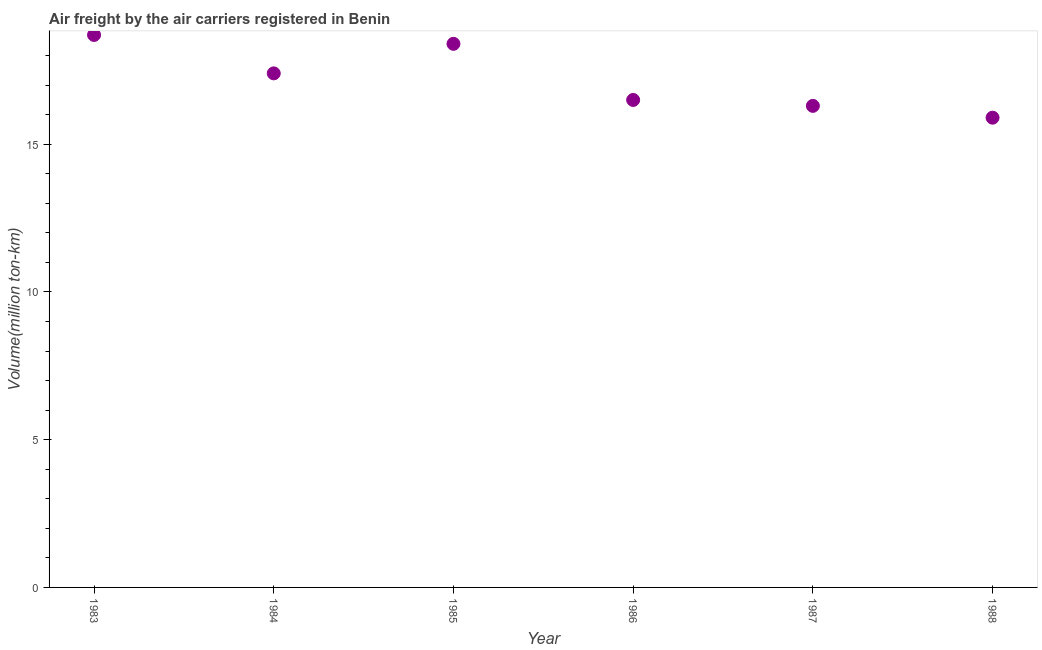What is the air freight in 1986?
Your response must be concise. 16.5. Across all years, what is the maximum air freight?
Keep it short and to the point. 18.7. Across all years, what is the minimum air freight?
Keep it short and to the point. 15.9. What is the sum of the air freight?
Your answer should be very brief. 103.2. What is the difference between the air freight in 1983 and 1986?
Offer a very short reply. 2.2. What is the average air freight per year?
Provide a short and direct response. 17.2. What is the median air freight?
Provide a succinct answer. 16.95. In how many years, is the air freight greater than 16 million ton-km?
Your answer should be compact. 5. Do a majority of the years between 1984 and 1983 (inclusive) have air freight greater than 8 million ton-km?
Offer a very short reply. No. What is the ratio of the air freight in 1984 to that in 1985?
Your answer should be compact. 0.95. Is the air freight in 1986 less than that in 1987?
Give a very brief answer. No. What is the difference between the highest and the second highest air freight?
Provide a short and direct response. 0.3. What is the difference between the highest and the lowest air freight?
Keep it short and to the point. 2.8. In how many years, is the air freight greater than the average air freight taken over all years?
Ensure brevity in your answer.  3. How many dotlines are there?
Provide a succinct answer. 1. What is the difference between two consecutive major ticks on the Y-axis?
Provide a succinct answer. 5. Does the graph contain grids?
Your response must be concise. No. What is the title of the graph?
Provide a succinct answer. Air freight by the air carriers registered in Benin. What is the label or title of the Y-axis?
Ensure brevity in your answer.  Volume(million ton-km). What is the Volume(million ton-km) in 1983?
Ensure brevity in your answer.  18.7. What is the Volume(million ton-km) in 1984?
Offer a terse response. 17.4. What is the Volume(million ton-km) in 1985?
Provide a succinct answer. 18.4. What is the Volume(million ton-km) in 1986?
Your response must be concise. 16.5. What is the Volume(million ton-km) in 1987?
Keep it short and to the point. 16.3. What is the Volume(million ton-km) in 1988?
Offer a terse response. 15.9. What is the difference between the Volume(million ton-km) in 1983 and 1984?
Offer a very short reply. 1.3. What is the difference between the Volume(million ton-km) in 1984 and 1985?
Your answer should be very brief. -1. What is the difference between the Volume(million ton-km) in 1984 and 1986?
Make the answer very short. 0.9. What is the difference between the Volume(million ton-km) in 1984 and 1987?
Provide a succinct answer. 1.1. What is the ratio of the Volume(million ton-km) in 1983 to that in 1984?
Give a very brief answer. 1.07. What is the ratio of the Volume(million ton-km) in 1983 to that in 1986?
Your answer should be very brief. 1.13. What is the ratio of the Volume(million ton-km) in 1983 to that in 1987?
Offer a terse response. 1.15. What is the ratio of the Volume(million ton-km) in 1983 to that in 1988?
Your response must be concise. 1.18. What is the ratio of the Volume(million ton-km) in 1984 to that in 1985?
Offer a terse response. 0.95. What is the ratio of the Volume(million ton-km) in 1984 to that in 1986?
Your response must be concise. 1.05. What is the ratio of the Volume(million ton-km) in 1984 to that in 1987?
Offer a very short reply. 1.07. What is the ratio of the Volume(million ton-km) in 1984 to that in 1988?
Ensure brevity in your answer.  1.09. What is the ratio of the Volume(million ton-km) in 1985 to that in 1986?
Offer a terse response. 1.11. What is the ratio of the Volume(million ton-km) in 1985 to that in 1987?
Keep it short and to the point. 1.13. What is the ratio of the Volume(million ton-km) in 1985 to that in 1988?
Offer a terse response. 1.16. What is the ratio of the Volume(million ton-km) in 1986 to that in 1988?
Your answer should be compact. 1.04. 